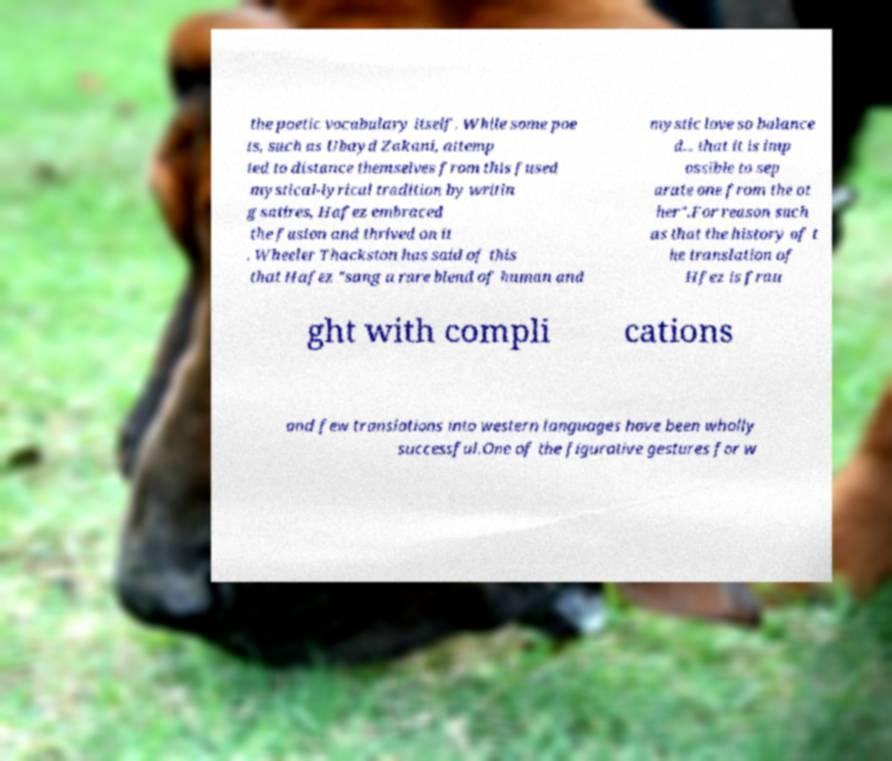Please identify and transcribe the text found in this image. the poetic vocabulary itself. While some poe ts, such as Ubayd Zakani, attemp ted to distance themselves from this fused mystical-lyrical tradition by writin g satires, Hafez embraced the fusion and thrived on it . Wheeler Thackston has said of this that Hafez "sang a rare blend of human and mystic love so balance d... that it is imp ossible to sep arate one from the ot her".For reason such as that the history of t he translation of Hfez is frau ght with compli cations and few translations into western languages have been wholly successful.One of the figurative gestures for w 